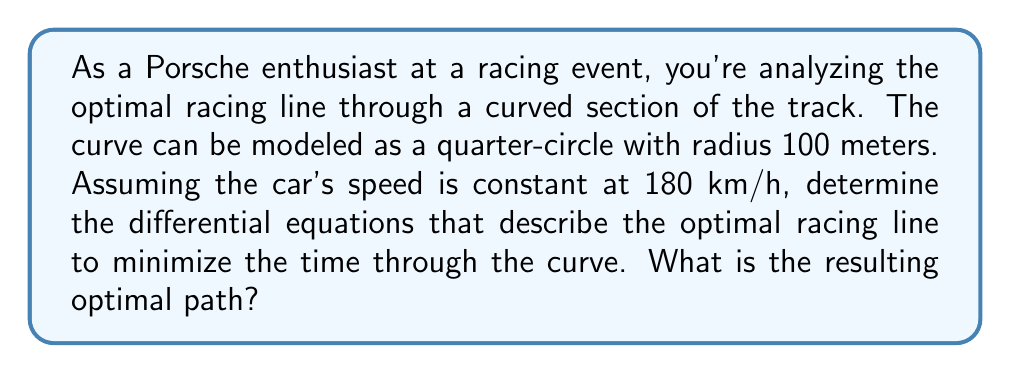Give your solution to this math problem. To solve this problem, we'll use the principles of optimal control theory and the calculus of variations. Let's approach this step-by-step:

1) First, we need to set up our coordinate system. Let's use polar coordinates $(r,\theta)$, where $r$ is the distance from the center of the curve and $\theta$ is the angle from the start of the curve.

2) The time to traverse the curve is given by:

   $$T = \int_0^{\pi/2} \frac{\sqrt{r^2 + (dr/d\theta)^2}}{v} d\theta$$

   where $v$ is the constant speed of the car.

3) Our goal is to minimize this time. According to the Euler-Lagrange equation, the optimal path satisfies:

   $$\frac{\partial L}{\partial r} - \frac{d}{d\theta}\left(\frac{\partial L}{\partial (dr/d\theta)}\right) = 0$$

   where $L = \frac{\sqrt{r^2 + (dr/d\theta)^2}}{v}$

4) Calculating the partial derivatives:

   $$\frac{\partial L}{\partial r} = \frac{r}{v\sqrt{r^2 + (dr/d\theta)^2}}$$

   $$\frac{\partial L}{\partial (dr/d\theta)} = \frac{dr/d\theta}{v\sqrt{r^2 + (dr/d\theta)^2}}$$

5) Substituting these into the Euler-Lagrange equation and simplifying, we get:

   $$\frac{d^2r}{d\theta^2} = r$$

6) This is a second-order linear differential equation. Its general solution is:

   $$r = A\cos\theta + B\sin\theta$$

7) To determine $A$ and $B$, we need boundary conditions. At $\theta = 0$, $r = 100$ (the car starts at the outside of the curve). At $\theta = \pi/2$, $r = 100$ (the car ends at the outside of the curve).

8) Applying these conditions:

   At $\theta = 0$: $100 = A$
   At $\theta = \pi/2$: $100 = B$

Therefore, the optimal path is described by:

   $$r = 100(\cos\theta + \sin\theta)$$

This equation represents a circular arc that cuts inside the original curve, allowing the car to take a smoother, faster line through the turn.
Answer: The optimal racing line through the curve is described by the polar equation:

$$r = 100(\cos\theta + \sin\theta)$$

where $r$ is in meters and $\theta$ is in radians, ranging from 0 to $\pi/2$. 